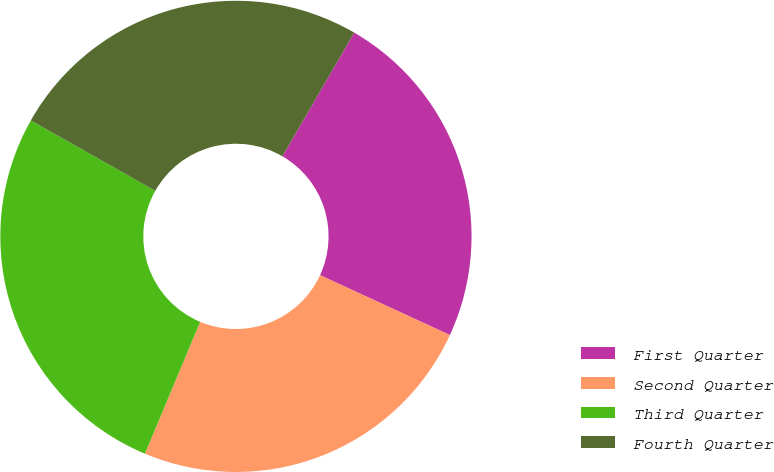<chart> <loc_0><loc_0><loc_500><loc_500><pie_chart><fcel>First Quarter<fcel>Second Quarter<fcel>Third Quarter<fcel>Fourth Quarter<nl><fcel>23.51%<fcel>24.43%<fcel>26.88%<fcel>25.18%<nl></chart> 